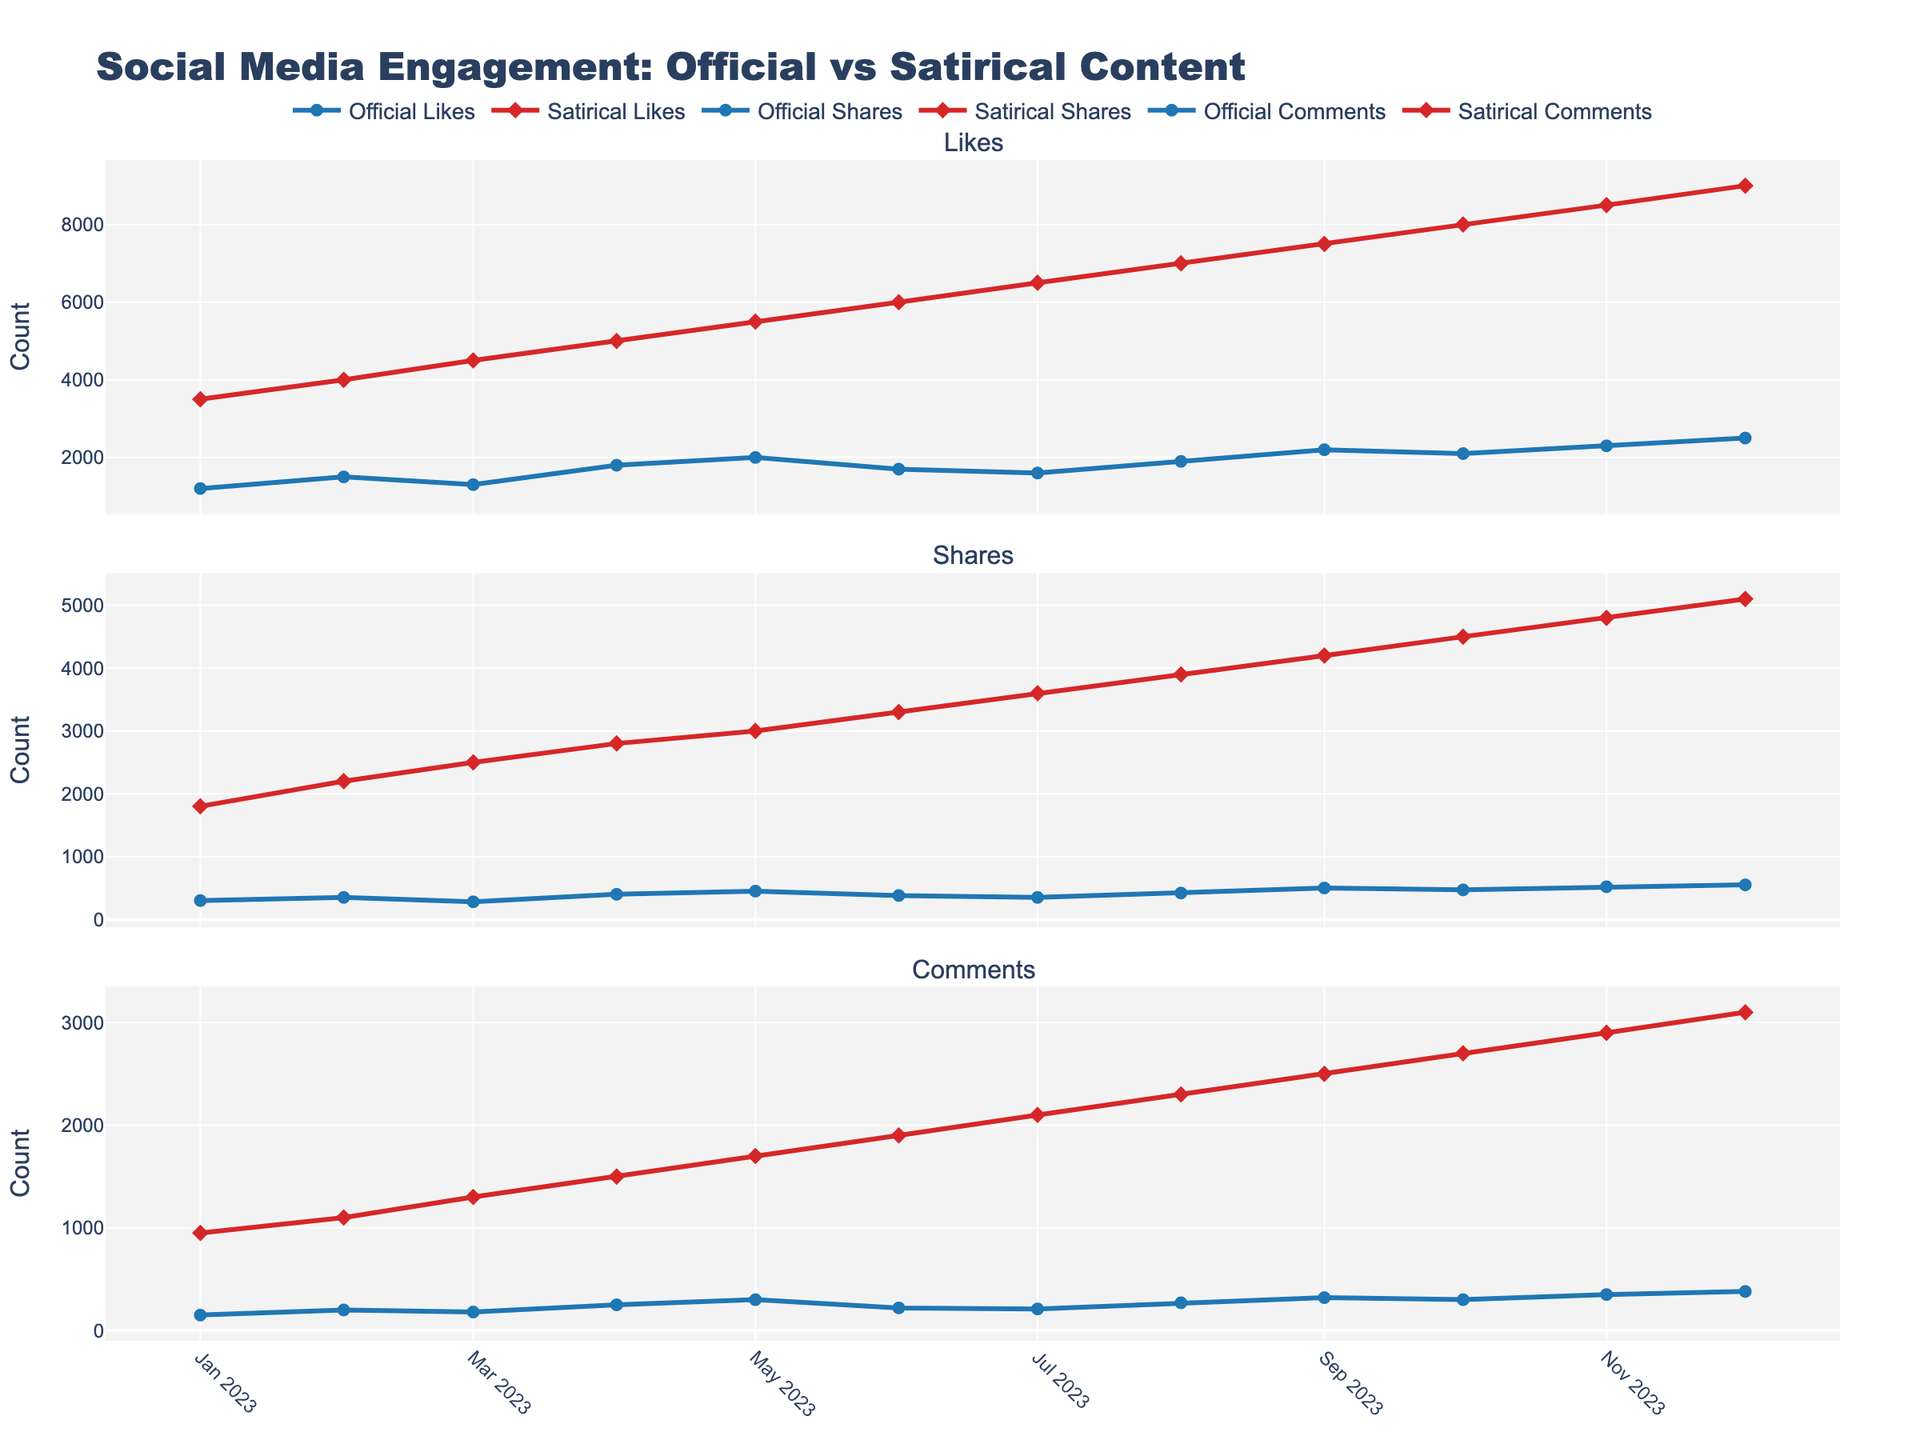Which type of content received the most likes in January? Compare the height of the 'Likes' line for both 'Official' and 'Satirical' content in January. 'Satirical' content received approximately 3500 likes, while 'Official' content received around 1200 likes. 'Satirical' content clearly has more likes.
Answer: Satirical By how much did the number of satirical shares increase from February to March? Examine the 'Satirical Shares' points for February and March. In February, it is 2200, and in March, it increases to 2500. The difference is 2500 - 2200.
Answer: 300 Which month shows the maximum difference in likes between official and satirical content? Compare the differences in 'Likes' for each month. For December, 'Official Likes' are 2500, and 'Satirical Likes' are 9000, resulting in a difference of 9000 - 2500 = 6500, which is the highest.
Answer: December What is the average number of official shares from January to March? Add the 'Official Shares' for January, February, and March (300 + 350 + 280), then divide by 3: (300 + 350 + 280) / 3.
Answer: 310 In which month did official comments exactly match satirical comments? Look at the 'Comments' lines for both 'Official' and 'Satirical'. In none of the months do the 'Official Comments' exactly match the 'Satirical Comments'.
Answer: None How do the trends in official versus satirical comments compare from April to July? Analyze the slopes of 'Official Comments' and 'Satirical Comments' lines from April to July. 'Satirical Comments' steadily increase, while 'Official Comments' show a slight decline.
Answer: Satirical increasing, Official declining What is the total number of shares for official content over the entire year? Sum the 'Official Shares' from January to December: 300 + 350 + 280 + 400 + 450 + 380 + 350 + 420 + 500 + 470 + 520 + 550.
Answer: 4970 Which has shown a greater absolute increase in comments from January to December: official or satirical content? Calculate the increase for both. 'Official Comments' rise from 150 to 380, resulting in 380 - 150 = 230. 'Satirical Comments' rise from 950 to 3100, resulting in 3100 - 950 = 2150.
Answer: Satirical In which month did satirical content first exceed 4000 shares? Observe the 'Satirical Shares' for each month to see when it first exceeds 4000. In April, 'Satirical Shares' are 2800. In May, they reach 3000. The first month that exceeds 4000 is June.
Answer: June Is there any month where the number of official likes outnumbers satirical likes? Compare the 'Likes' lines month by month for both 'Official' and 'Satirical'. In none of the months do the 'Official Likes' outnumber the 'Satirical Likes'.
Answer: No 